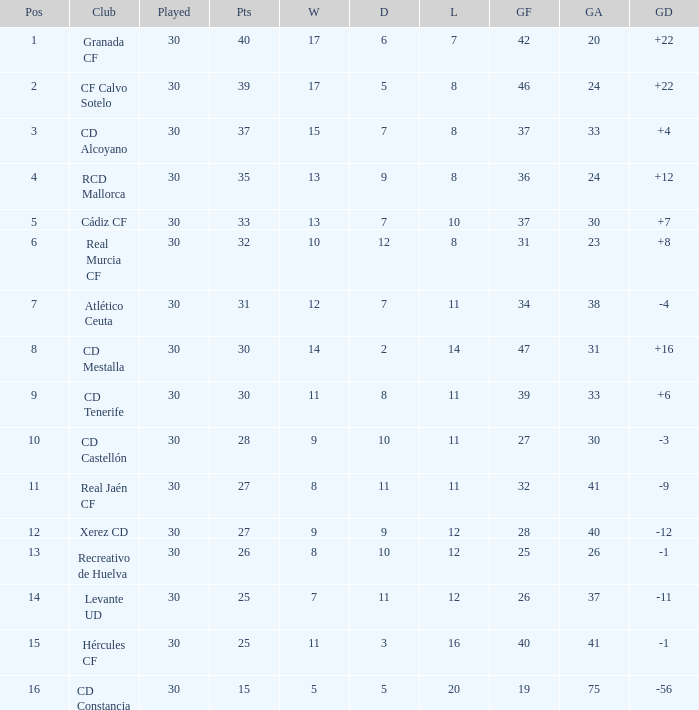Which Played has a Club of atlético ceuta, and less than 11 Losses? None. 